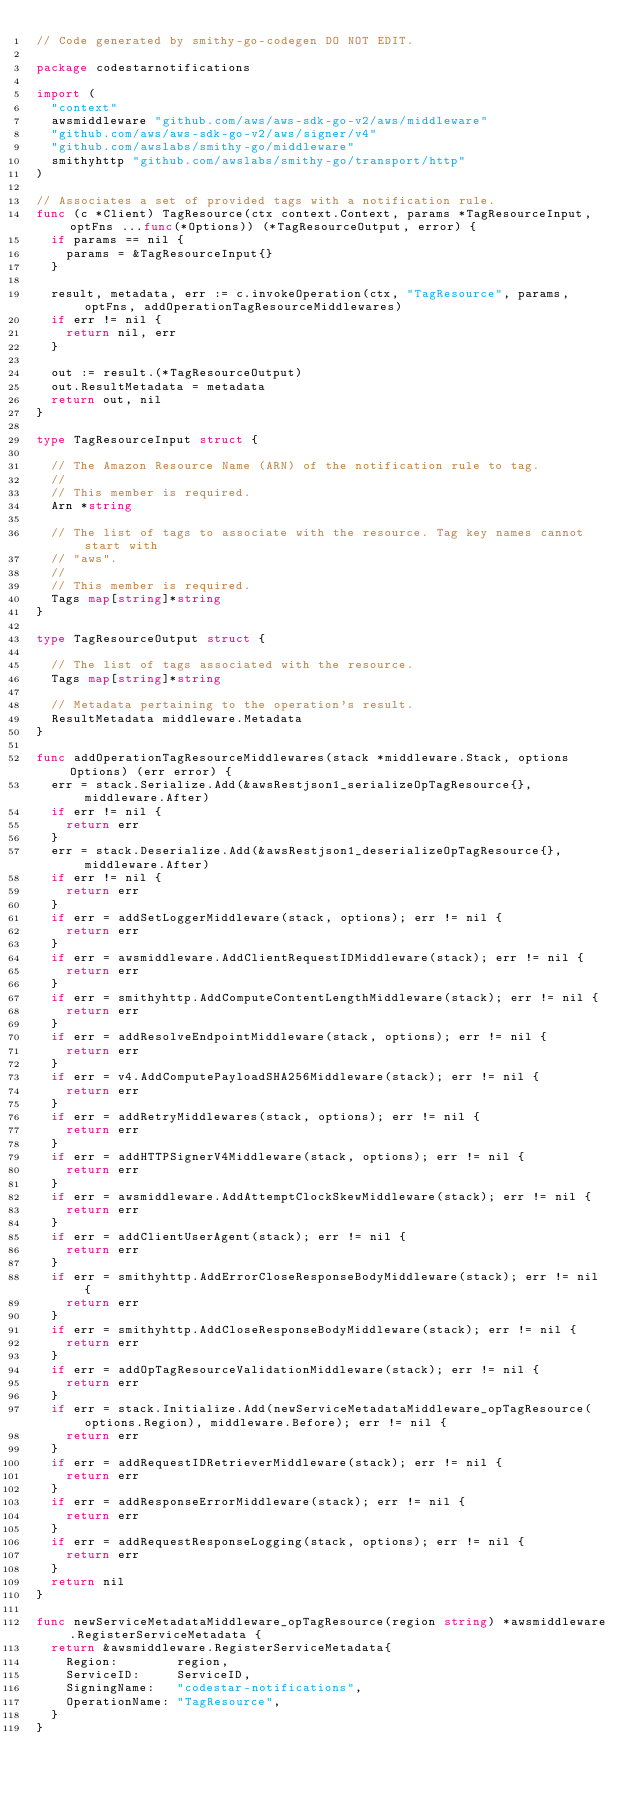Convert code to text. <code><loc_0><loc_0><loc_500><loc_500><_Go_>// Code generated by smithy-go-codegen DO NOT EDIT.

package codestarnotifications

import (
	"context"
	awsmiddleware "github.com/aws/aws-sdk-go-v2/aws/middleware"
	"github.com/aws/aws-sdk-go-v2/aws/signer/v4"
	"github.com/awslabs/smithy-go/middleware"
	smithyhttp "github.com/awslabs/smithy-go/transport/http"
)

// Associates a set of provided tags with a notification rule.
func (c *Client) TagResource(ctx context.Context, params *TagResourceInput, optFns ...func(*Options)) (*TagResourceOutput, error) {
	if params == nil {
		params = &TagResourceInput{}
	}

	result, metadata, err := c.invokeOperation(ctx, "TagResource", params, optFns, addOperationTagResourceMiddlewares)
	if err != nil {
		return nil, err
	}

	out := result.(*TagResourceOutput)
	out.ResultMetadata = metadata
	return out, nil
}

type TagResourceInput struct {

	// The Amazon Resource Name (ARN) of the notification rule to tag.
	//
	// This member is required.
	Arn *string

	// The list of tags to associate with the resource. Tag key names cannot start with
	// "aws".
	//
	// This member is required.
	Tags map[string]*string
}

type TagResourceOutput struct {

	// The list of tags associated with the resource.
	Tags map[string]*string

	// Metadata pertaining to the operation's result.
	ResultMetadata middleware.Metadata
}

func addOperationTagResourceMiddlewares(stack *middleware.Stack, options Options) (err error) {
	err = stack.Serialize.Add(&awsRestjson1_serializeOpTagResource{}, middleware.After)
	if err != nil {
		return err
	}
	err = stack.Deserialize.Add(&awsRestjson1_deserializeOpTagResource{}, middleware.After)
	if err != nil {
		return err
	}
	if err = addSetLoggerMiddleware(stack, options); err != nil {
		return err
	}
	if err = awsmiddleware.AddClientRequestIDMiddleware(stack); err != nil {
		return err
	}
	if err = smithyhttp.AddComputeContentLengthMiddleware(stack); err != nil {
		return err
	}
	if err = addResolveEndpointMiddleware(stack, options); err != nil {
		return err
	}
	if err = v4.AddComputePayloadSHA256Middleware(stack); err != nil {
		return err
	}
	if err = addRetryMiddlewares(stack, options); err != nil {
		return err
	}
	if err = addHTTPSignerV4Middleware(stack, options); err != nil {
		return err
	}
	if err = awsmiddleware.AddAttemptClockSkewMiddleware(stack); err != nil {
		return err
	}
	if err = addClientUserAgent(stack); err != nil {
		return err
	}
	if err = smithyhttp.AddErrorCloseResponseBodyMiddleware(stack); err != nil {
		return err
	}
	if err = smithyhttp.AddCloseResponseBodyMiddleware(stack); err != nil {
		return err
	}
	if err = addOpTagResourceValidationMiddleware(stack); err != nil {
		return err
	}
	if err = stack.Initialize.Add(newServiceMetadataMiddleware_opTagResource(options.Region), middleware.Before); err != nil {
		return err
	}
	if err = addRequestIDRetrieverMiddleware(stack); err != nil {
		return err
	}
	if err = addResponseErrorMiddleware(stack); err != nil {
		return err
	}
	if err = addRequestResponseLogging(stack, options); err != nil {
		return err
	}
	return nil
}

func newServiceMetadataMiddleware_opTagResource(region string) *awsmiddleware.RegisterServiceMetadata {
	return &awsmiddleware.RegisterServiceMetadata{
		Region:        region,
		ServiceID:     ServiceID,
		SigningName:   "codestar-notifications",
		OperationName: "TagResource",
	}
}
</code> 